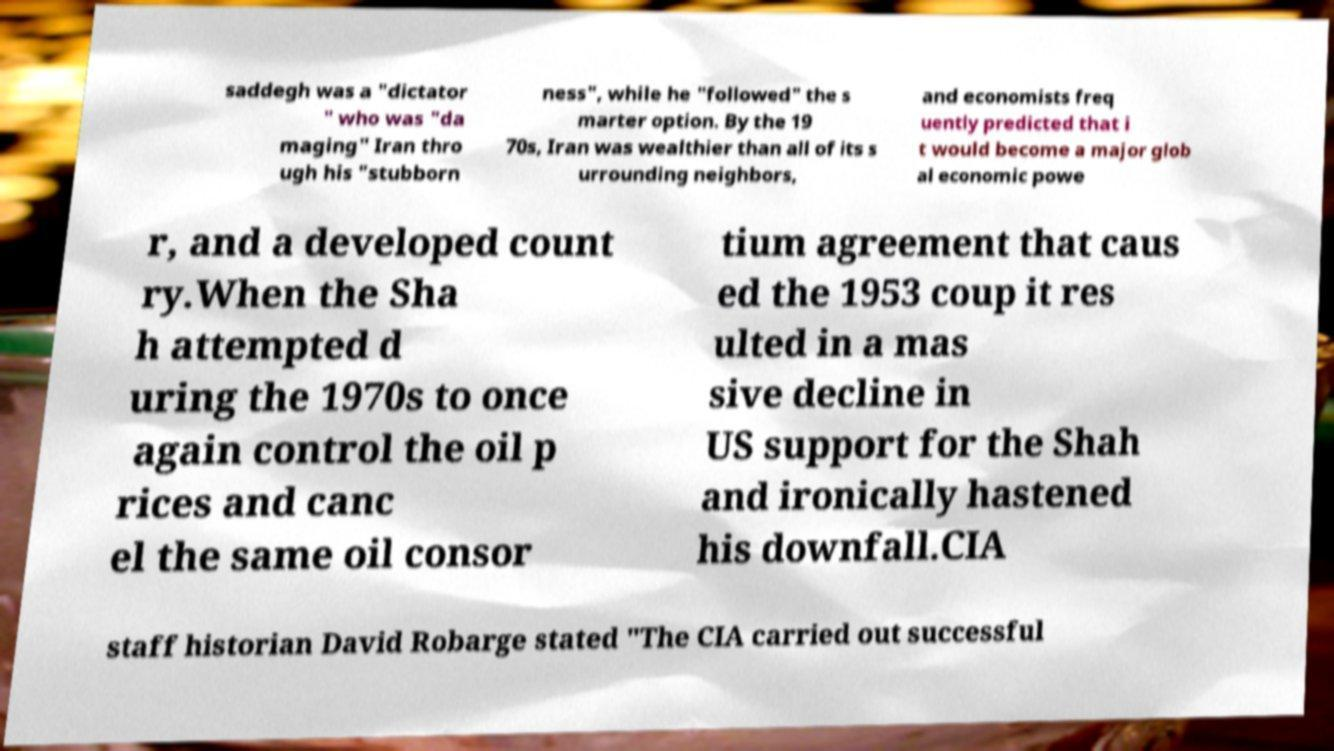There's text embedded in this image that I need extracted. Can you transcribe it verbatim? saddegh was a "dictator " who was "da maging" Iran thro ugh his "stubborn ness", while he "followed" the s marter option. By the 19 70s, Iran was wealthier than all of its s urrounding neighbors, and economists freq uently predicted that i t would become a major glob al economic powe r, and a developed count ry.When the Sha h attempted d uring the 1970s to once again control the oil p rices and canc el the same oil consor tium agreement that caus ed the 1953 coup it res ulted in a mas sive decline in US support for the Shah and ironically hastened his downfall.CIA staff historian David Robarge stated "The CIA carried out successful 